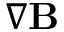<formula> <loc_0><loc_0><loc_500><loc_500>\nabla B</formula> 